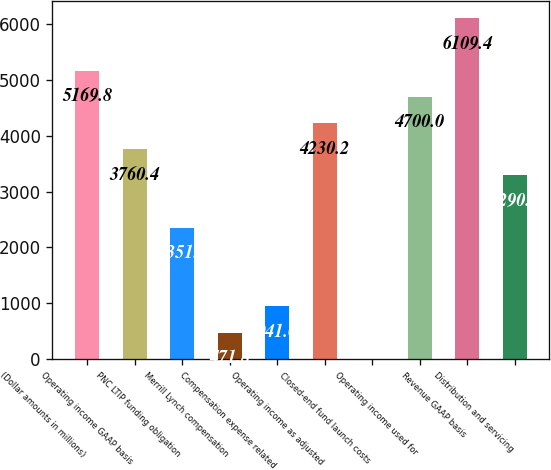Convert chart to OTSL. <chart><loc_0><loc_0><loc_500><loc_500><bar_chart><fcel>(Dollar amounts in millions)<fcel>Operating income GAAP basis<fcel>PNC LTIP funding obligation<fcel>Merrill Lynch compensation<fcel>Compensation expense related<fcel>Operating income as adjusted<fcel>Closed-end fund launch costs<fcel>Operating income used for<fcel>Revenue GAAP basis<fcel>Distribution and servicing<nl><fcel>5169.8<fcel>3760.4<fcel>2351<fcel>471.8<fcel>941.6<fcel>4230.2<fcel>2<fcel>4700<fcel>6109.4<fcel>3290.6<nl></chart> 